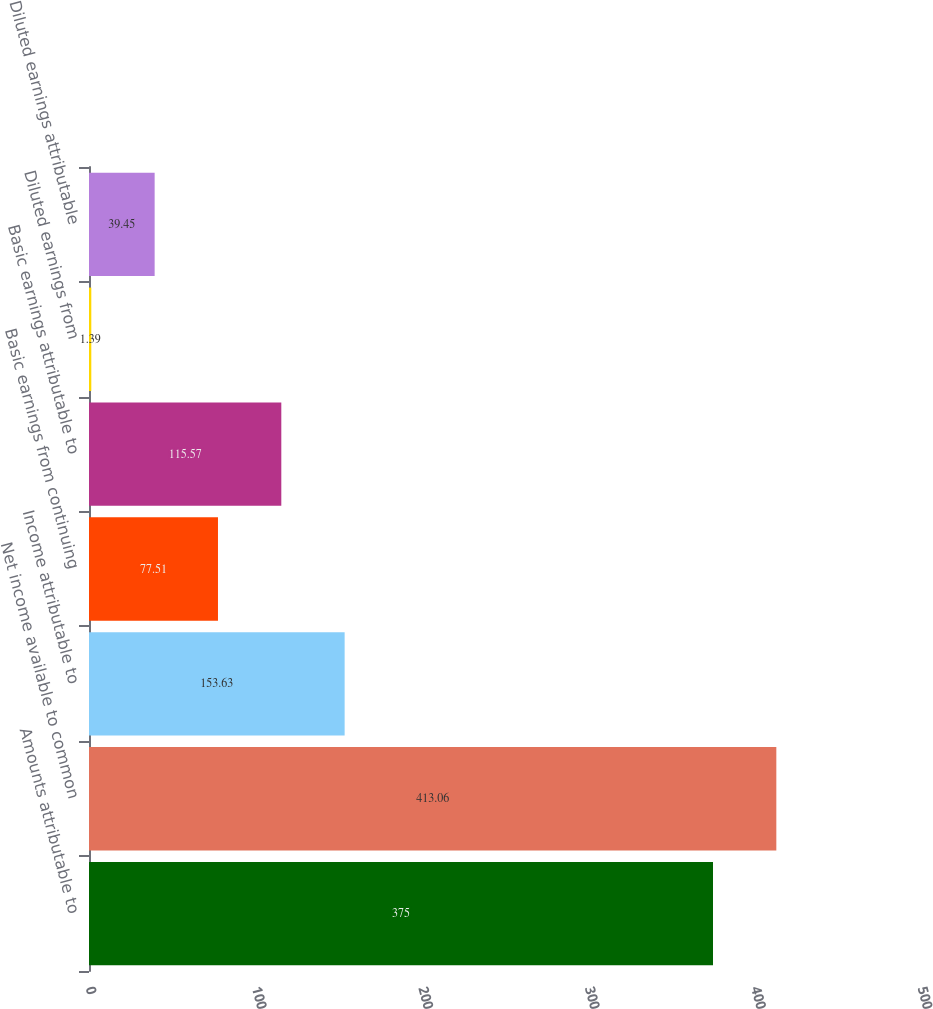Convert chart to OTSL. <chart><loc_0><loc_0><loc_500><loc_500><bar_chart><fcel>Amounts attributable to<fcel>Net income available to common<fcel>Income attributable to<fcel>Basic earnings from continuing<fcel>Basic earnings attributable to<fcel>Diluted earnings from<fcel>Diluted earnings attributable<nl><fcel>375<fcel>413.06<fcel>153.63<fcel>77.51<fcel>115.57<fcel>1.39<fcel>39.45<nl></chart> 